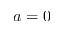Convert formula to latex. <formula><loc_0><loc_0><loc_500><loc_500>a = 0</formula> 